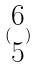Convert formula to latex. <formula><loc_0><loc_0><loc_500><loc_500>( \begin{matrix} 6 \\ 5 \end{matrix} )</formula> 